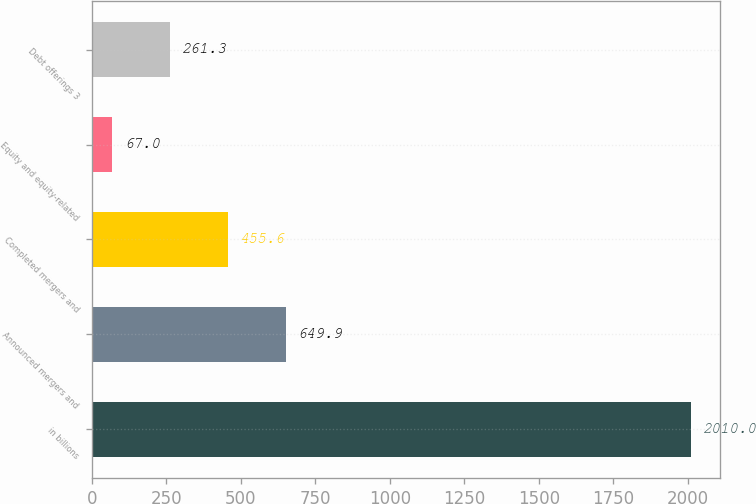<chart> <loc_0><loc_0><loc_500><loc_500><bar_chart><fcel>in billions<fcel>Announced mergers and<fcel>Completed mergers and<fcel>Equity and equity-related<fcel>Debt offerings 3<nl><fcel>2010<fcel>649.9<fcel>455.6<fcel>67<fcel>261.3<nl></chart> 